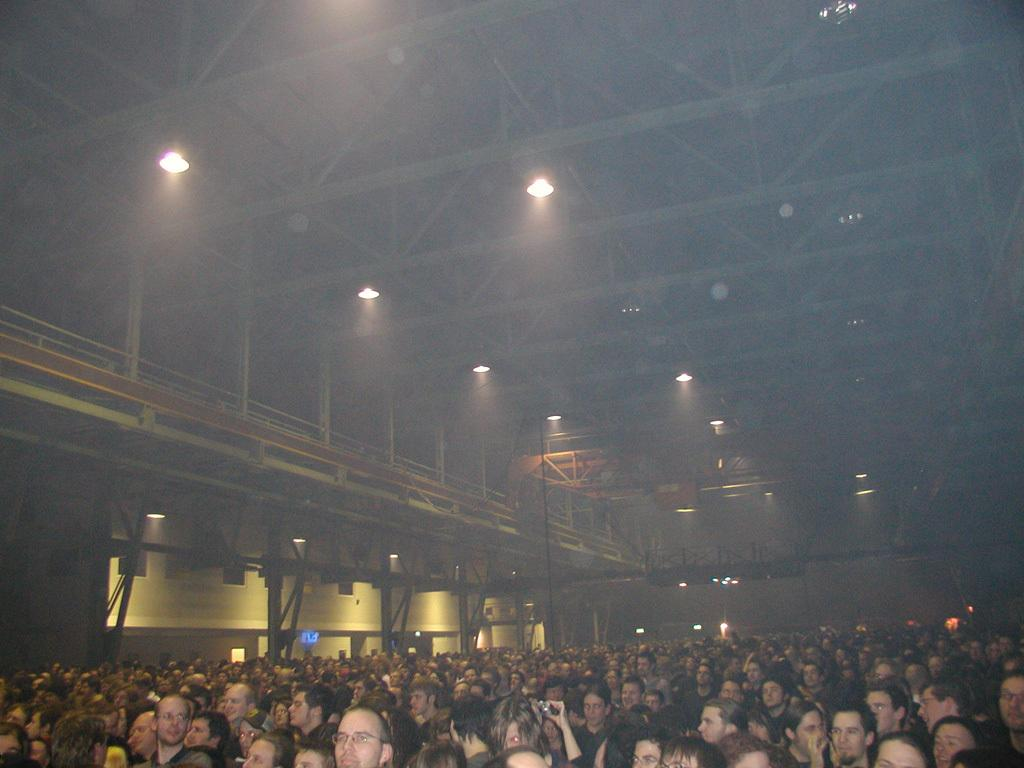What are the people in the image doing? The people in the image are sitting on chairs. What type of lighting is present in the image? Electric lights are visible in the image. What type of architectural feature can be seen in the image? Iron grills and pillars are present in the image. What else can be seen in the image that is not related to people or lighting? Poles are visible in the image. How many pizzas are being served on the cloud in the image? There are no pizzas or clouds present in the image. What type of light is emitted from the light source in the image? The image does not specify the type of light emitted from the electric lights, only that they are visible. 